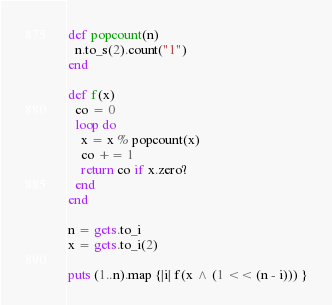<code> <loc_0><loc_0><loc_500><loc_500><_Ruby_>def popcount(n)
  n.to_s(2).count("1")
end

def f(x)
  co = 0
  loop do
    x = x % popcount(x)
    co += 1
    return co if x.zero?
  end
end

n = gets.to_i
x = gets.to_i(2)

puts (1..n).map {|i| f(x ^ (1 << (n - i))) }</code> 